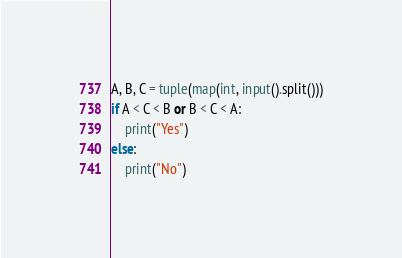Convert code to text. <code><loc_0><loc_0><loc_500><loc_500><_Python_>A, B, C = tuple(map(int, input().split()))
if A < C < B or B < C < A:
    print("Yes")
else:
    print("No")</code> 